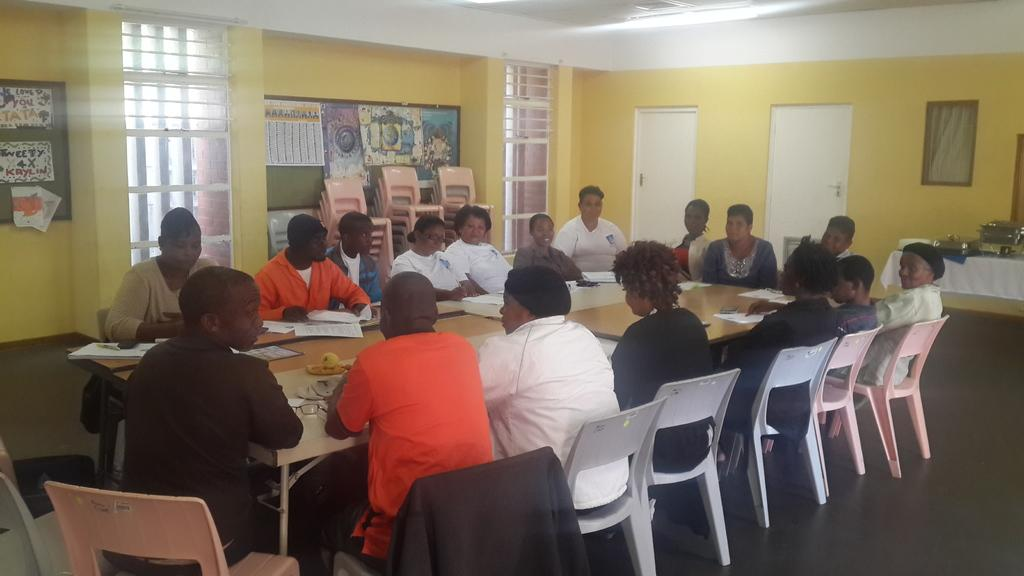What is happening in the image involving a group of people? There is a group of people in the image, and they are sitting on a chair discussing something important. Can you describe the seating arrangement in the image? The people are sitting on a chair, and there are additional chairs visible in the background of the image. What can be seen in the background of the image? In the background of the image, there are doors visible. What type of toothpaste is the farmer using to extract a worm from the ground in the image? There is no toothpaste, farmer, or worm present in the image. 